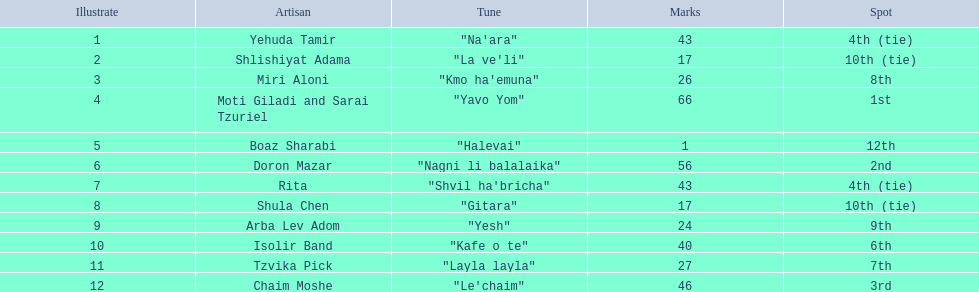What are the number of times an artist earned first place? 1. 